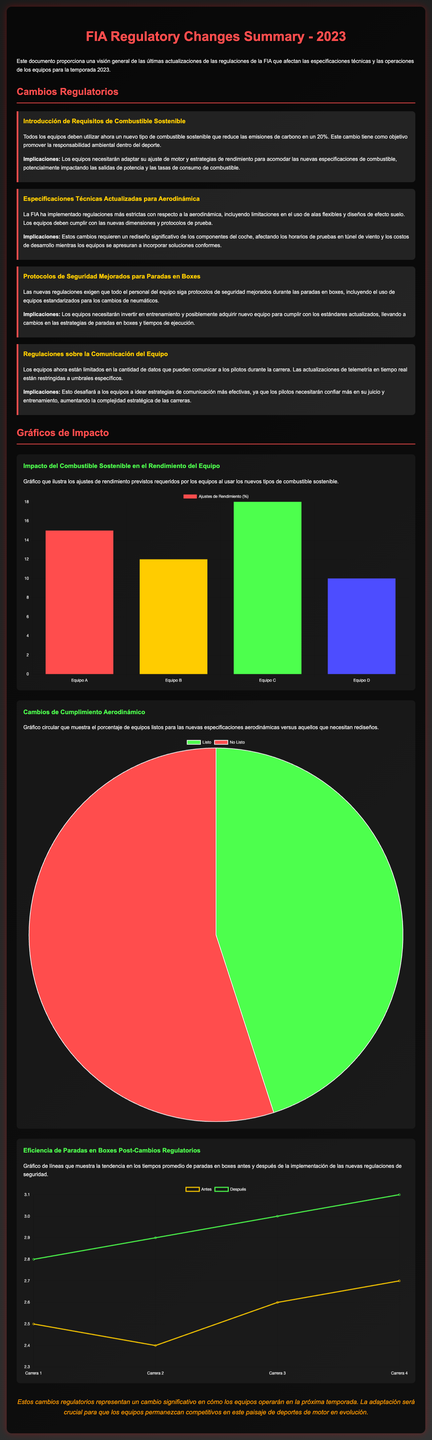¿Qué porcentaje de reducción de emisiones de carbono se espera con el nuevo combustible sostenible? La cifra proporcionada en el documento indica que se espera una reducción del 20% en las emisiones de carbono.
Answer: 20% ¿Cuál es el efecto secundario esperado de las nuevas especificaciones de combustible en los equipos? El documento menciona que los equipos tendrán que adaptar su ajuste de motor y estrategias de rendimiento, impactando las salidas de potencia y las tasas de consumo de combustible.
Answer: Adaptar ajuste de motor y estrategias de rendimiento ¿Cuántos equipos están listos para las nuevas especificaciones aerodinámicas? El gráfico indica que el 45% de los equipos están listos, mientras que el 55% no lo están.
Answer: 45% ¿Qué cambio se exige en las paradas en boxes según las nuevas regulaciones? Las nuevas regulaciones exigen protocolos de seguridad mejorados y el uso de equipos estandarizados para los cambios de neumáticos.
Answer: Protocolos de seguridad mejorados ¿Cuál es la tendencia de los tiempos promedio de paradas en boxes antes y después de los cambios regulatorios? El gráfico de líneas muestra que los tiempos de paradas en boxes han aumentado después de los cambios regulatorios, lo que sugiere que estos están siendo menos eficientes.
Answer: Aumento de tiempos ¿Qué colores dominan en el gráfico de impacto del combustible sostenible? El gráfico utiliza los colores rojo, amarillo, verde y azul para representar a los equipos y sus ajustes de rendimiento.
Answer: Rojo, amarillo, verde, azul ¿Cuál es el impacto de las nuevas regulaciones en la comunicación del equipo? El documento menciona que los equipos están limitados en la cantidad de datos que pueden comunicar a los pilotos durante la carrera.
Answer: Limitación en comunicación ¿Qué tipo de gráfico se utiliza para mostrar la eficiencia de las paradas en boxes? Se utiliza un gráfico de líneas para ilustrar la tendencia en los tiempos promedio de paradas en boxes antes y después de las nuevas regulaciones.
Answer: Gráfico de líneas 